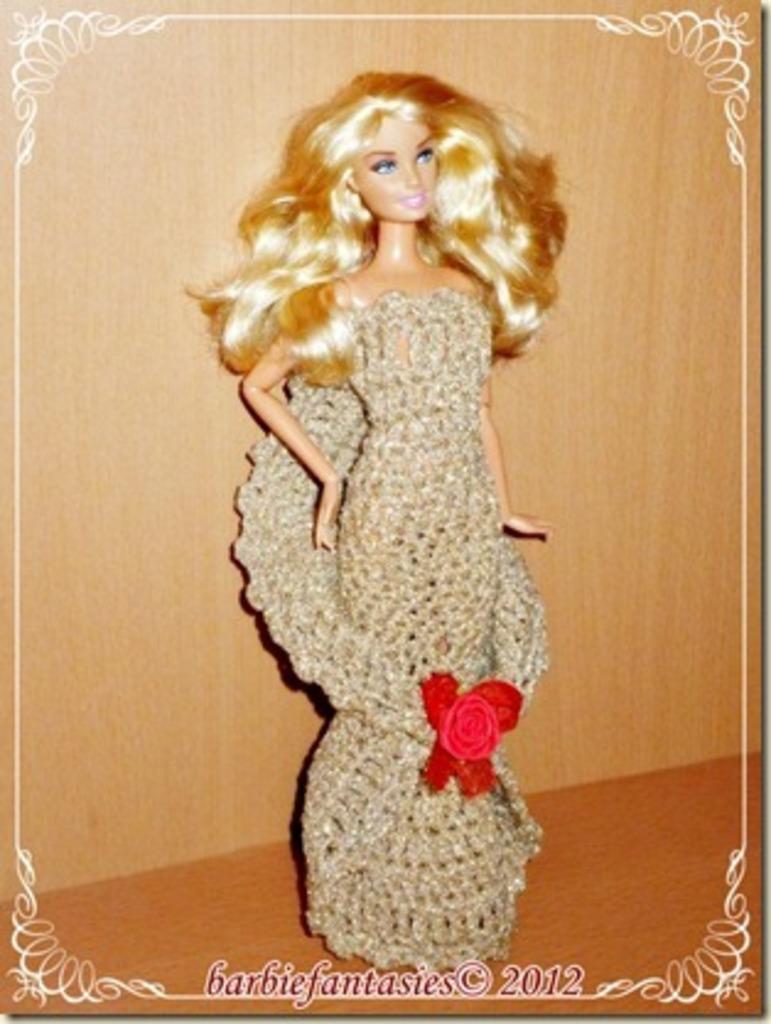In one or two sentences, can you explain what this image depicts? In this image in the center there is one toy and in the background there is a wall, and at the bottom of the image there is some text. 